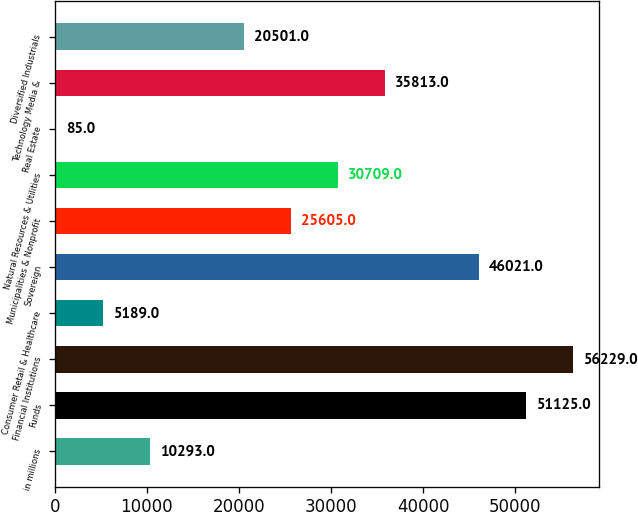Convert chart. <chart><loc_0><loc_0><loc_500><loc_500><bar_chart><fcel>in millions<fcel>Funds<fcel>Financial Institutions<fcel>Consumer Retail & Healthcare<fcel>Sovereign<fcel>Municipalities & Nonprofit<fcel>Natural Resources & Utilities<fcel>Real Estate<fcel>Technology Media &<fcel>Diversified Industrials<nl><fcel>10293<fcel>51125<fcel>56229<fcel>5189<fcel>46021<fcel>25605<fcel>30709<fcel>85<fcel>35813<fcel>20501<nl></chart> 